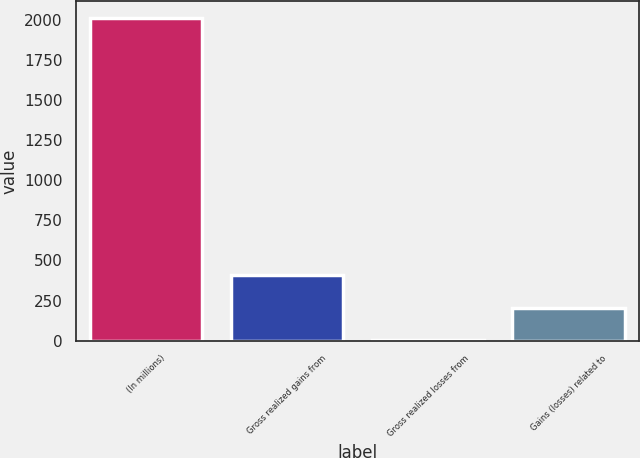Convert chart to OTSL. <chart><loc_0><loc_0><loc_500><loc_500><bar_chart><fcel>(In millions)<fcel>Gross realized gains from<fcel>Gross realized losses from<fcel>Gains (losses) related to<nl><fcel>2016<fcel>407.2<fcel>5<fcel>206.1<nl></chart> 